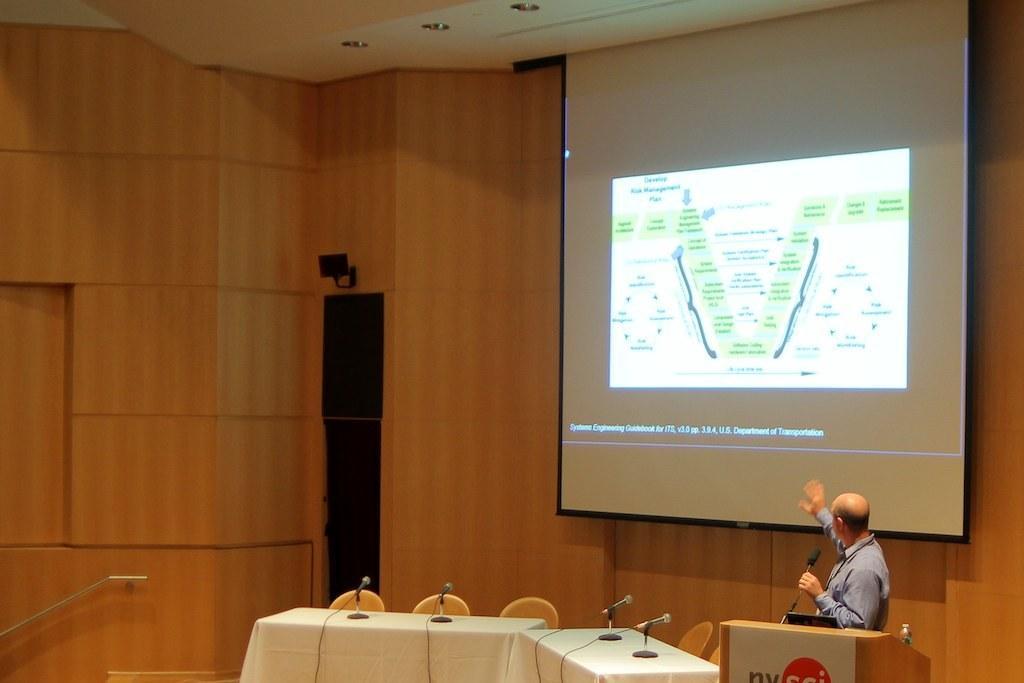Could you give a brief overview of what you see in this image? In this image I can see the person standing in front of the podium and I can also see few microphones, chairs. In the background I can see the projection screen and I can see the wooden wall in brown color. 